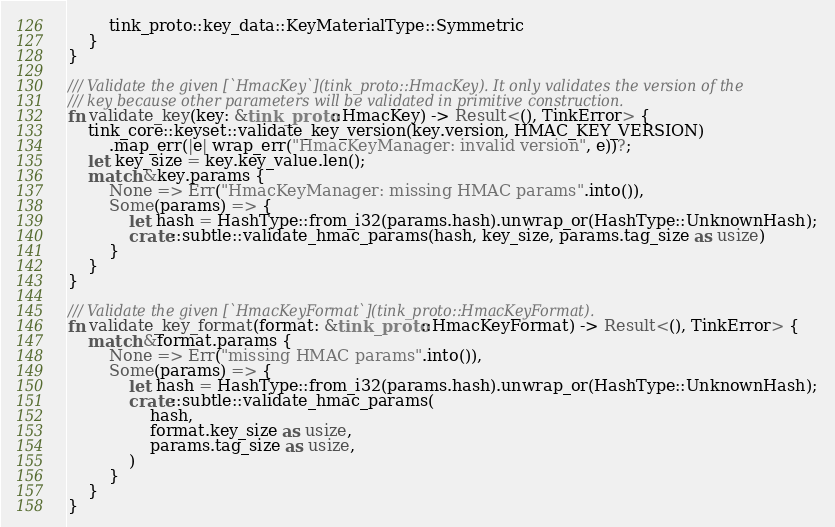Convert code to text. <code><loc_0><loc_0><loc_500><loc_500><_Rust_>        tink_proto::key_data::KeyMaterialType::Symmetric
    }
}

/// Validate the given [`HmacKey`](tink_proto::HmacKey). It only validates the version of the
/// key because other parameters will be validated in primitive construction.
fn validate_key(key: &tink_proto::HmacKey) -> Result<(), TinkError> {
    tink_core::keyset::validate_key_version(key.version, HMAC_KEY_VERSION)
        .map_err(|e| wrap_err("HmacKeyManager: invalid version", e))?;
    let key_size = key.key_value.len();
    match &key.params {
        None => Err("HmacKeyManager: missing HMAC params".into()),
        Some(params) => {
            let hash = HashType::from_i32(params.hash).unwrap_or(HashType::UnknownHash);
            crate::subtle::validate_hmac_params(hash, key_size, params.tag_size as usize)
        }
    }
}

/// Validate the given [`HmacKeyFormat`](tink_proto::HmacKeyFormat).
fn validate_key_format(format: &tink_proto::HmacKeyFormat) -> Result<(), TinkError> {
    match &format.params {
        None => Err("missing HMAC params".into()),
        Some(params) => {
            let hash = HashType::from_i32(params.hash).unwrap_or(HashType::UnknownHash);
            crate::subtle::validate_hmac_params(
                hash,
                format.key_size as usize,
                params.tag_size as usize,
            )
        }
    }
}
</code> 